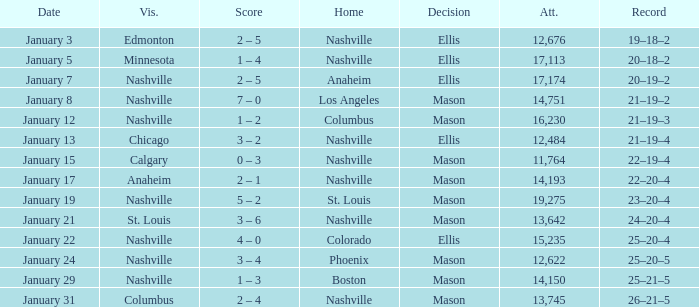On January 15, what was the most in attendance? 11764.0. 